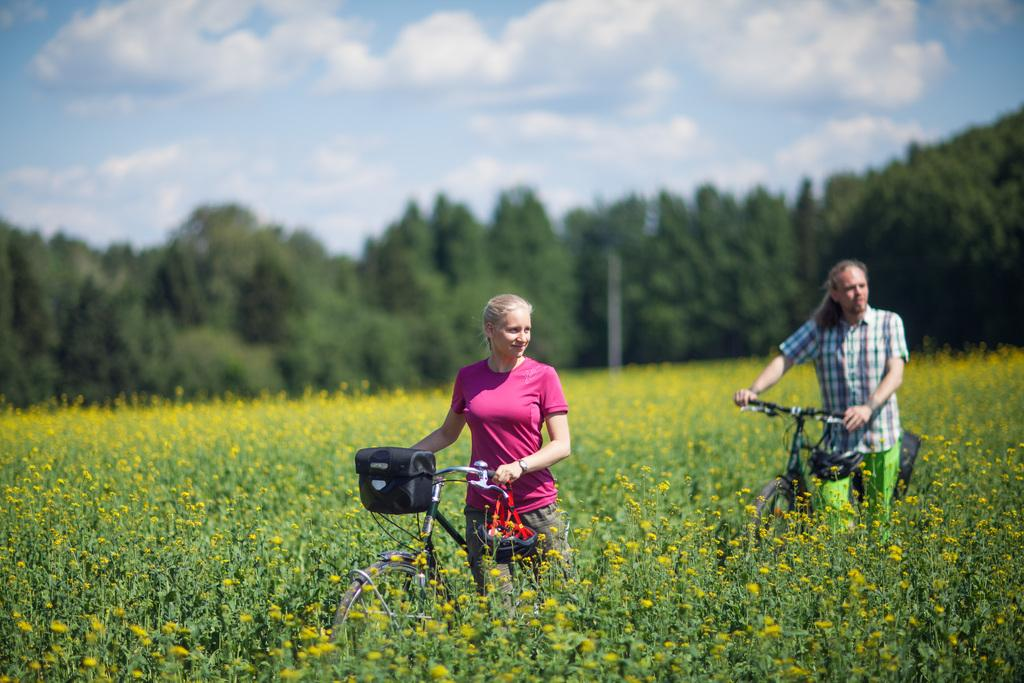What type of living organisms can be seen in the image? Plants can be seen in the image. How many people are present in the image? There are two persons in the image. What are the persons holding in the image? The persons are holding a bicycle. Where are the persons standing in the image? The persons are standing on the ground. What is visible at the top of the image? The sky is visible at the top of the image. What type of vegetation is present in the image? There are trees in the image. What shape is the stick that the persons are using to ride the bicycle in the image? There is no stick present in the image, and the persons are not riding the bicycle; they are holding it. What type of square can be seen in the image? There is no square present in the image. 